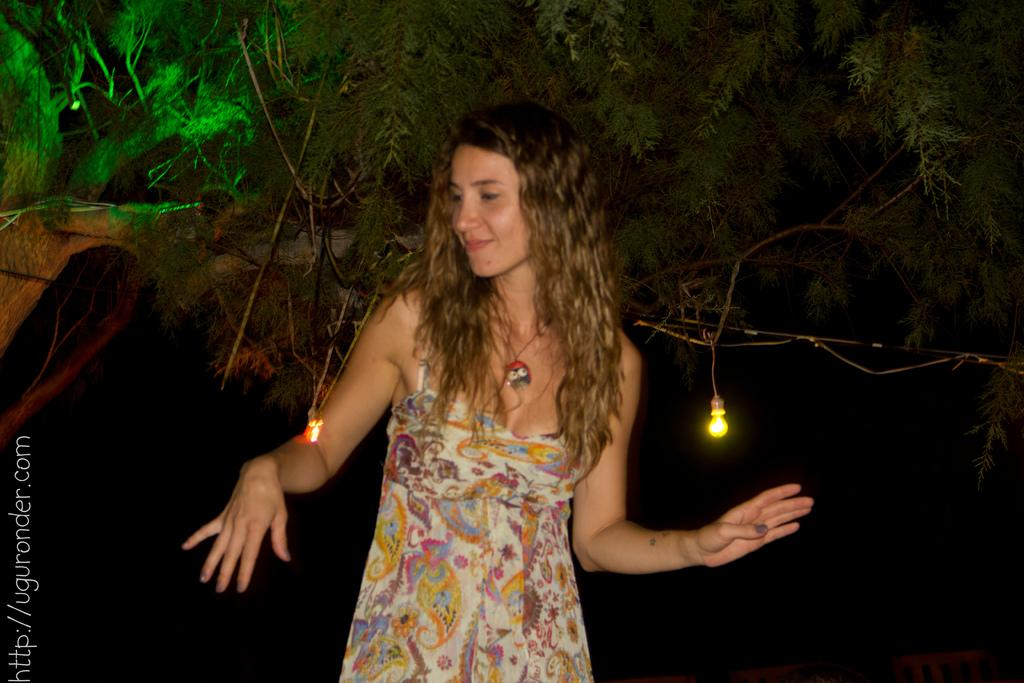What is the main subject in the image? There is a woman standing in the image. Can you describe anything else on the left side of the image? There is text on the left side of the image. What can be seen attached to the big tree in the image? There are two lights attached to a big tree in the image. Are there any fairies flying around the big tree in the image? There is no mention of fairies in the image, so we cannot confirm their presence. Can you see a mountain in the background of the image? The provided facts do not mention a mountain, so we cannot confirm its presence. 